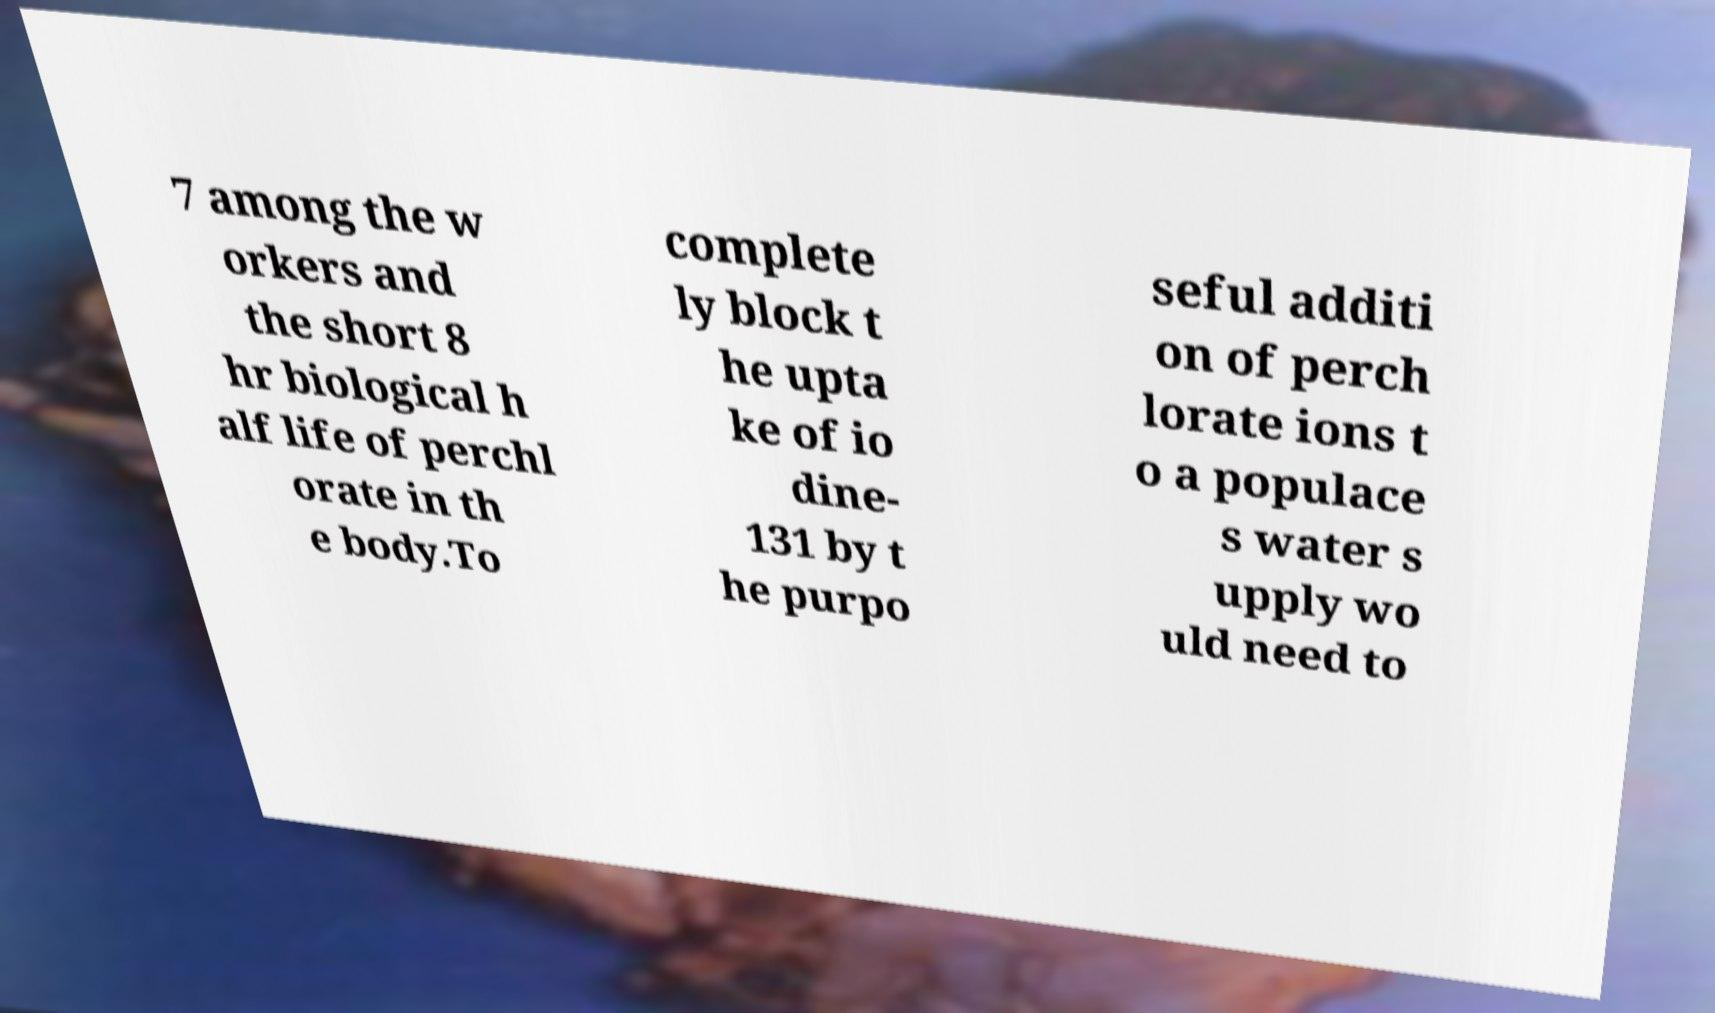Can you read and provide the text displayed in the image?This photo seems to have some interesting text. Can you extract and type it out for me? 7 among the w orkers and the short 8 hr biological h alf life of perchl orate in th e body.To complete ly block t he upta ke of io dine- 131 by t he purpo seful additi on of perch lorate ions t o a populace s water s upply wo uld need to 